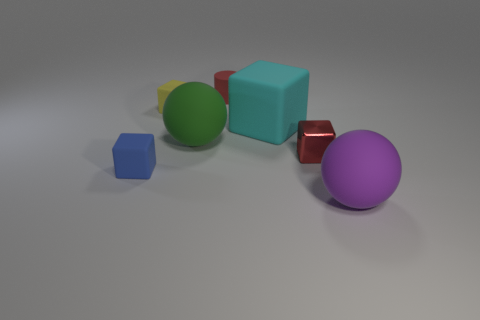Add 3 yellow rubber things. How many objects exist? 10 Subtract all brown cubes. Subtract all red cylinders. How many cubes are left? 4 Subtract all balls. How many objects are left? 5 Add 3 big matte things. How many big matte things are left? 6 Add 2 big cyan cylinders. How many big cyan cylinders exist? 2 Subtract 1 red blocks. How many objects are left? 6 Subtract all cyan cubes. Subtract all green matte spheres. How many objects are left? 5 